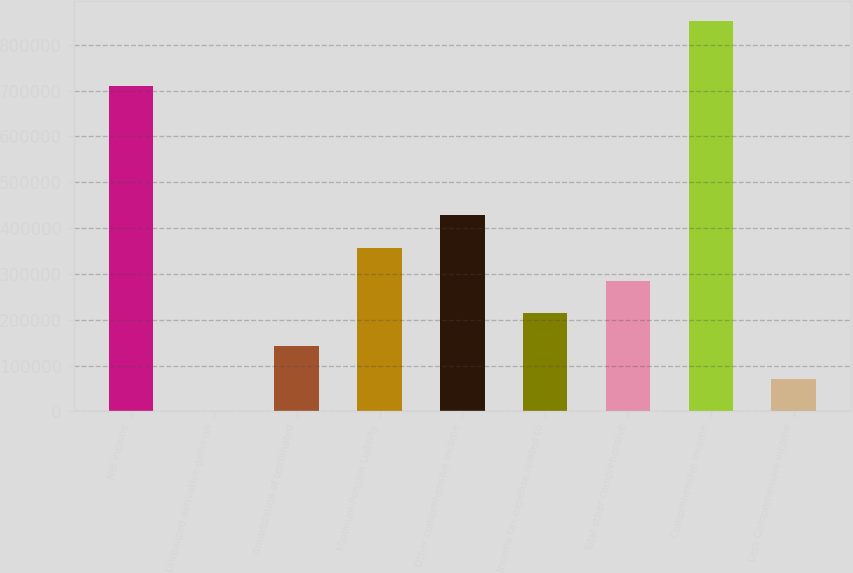Convert chart. <chart><loc_0><loc_0><loc_500><loc_500><bar_chart><fcel>Net income<fcel>Unrealized derivative gains on<fcel>Amortization of terminated<fcel>Minimum Pension Liability<fcel>Other comprehensive income<fcel>Income tax expense related to<fcel>Total other comprehensive<fcel>Comprehensive income<fcel>Less Comprehensive income<nl><fcel>709889<fcel>1.67<fcel>142597<fcel>356489<fcel>427787<fcel>213894<fcel>285192<fcel>852484<fcel>71299.2<nl></chart> 